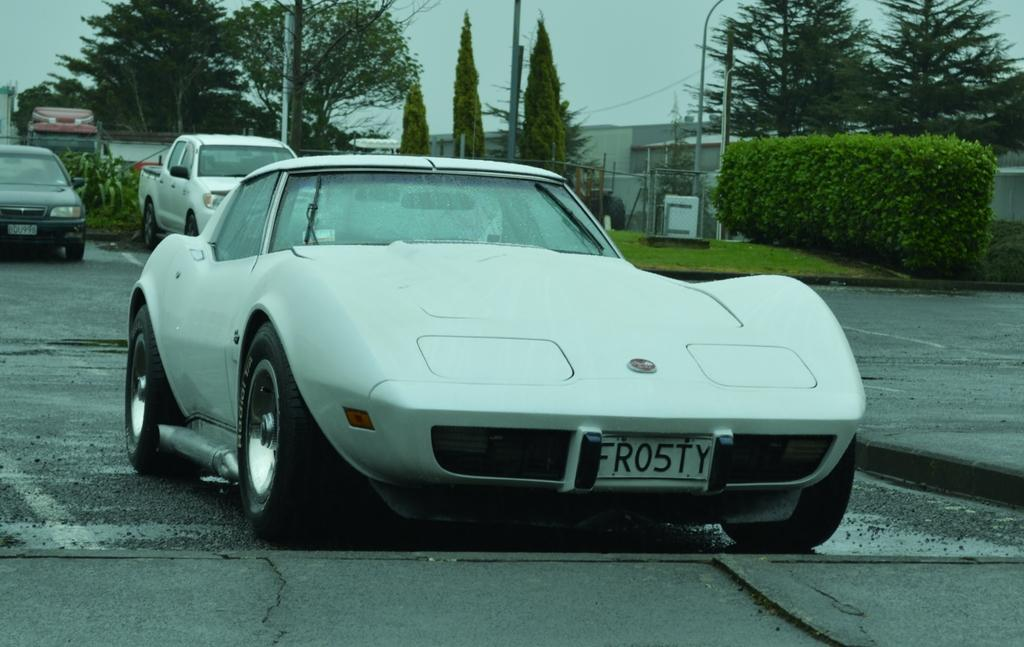What can be seen on the road in the image? There are cars on the road in the image. What is visible in the background of the image? There are trees, poles, plants, grassy land, and a building in the background of the image. What is the color of the sky in the image? The sky is white in color. What angle is the building leaning at in the image? There is no indication in the image that the building is leaning at any angle. Does the existence of the building in the image prove the existence of a parallel universe? The presence of a building in the image does not provide any evidence for the existence of a parallel universe. 